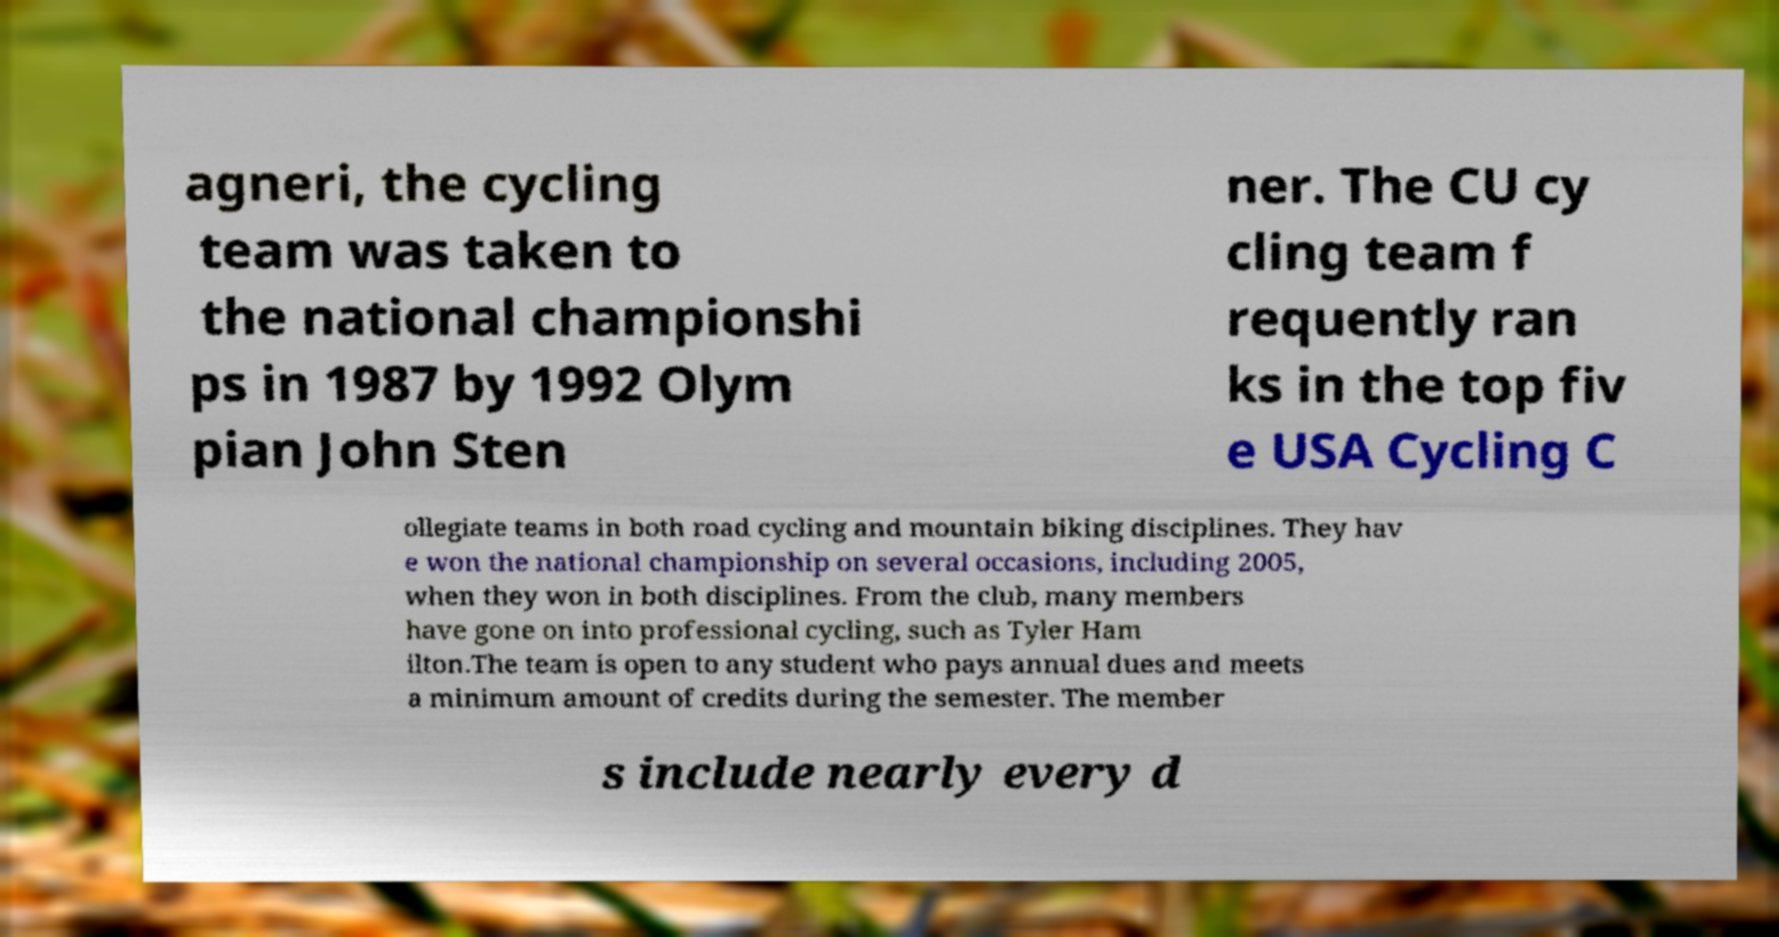Could you extract and type out the text from this image? agneri, the cycling team was taken to the national championshi ps in 1987 by 1992 Olym pian John Sten ner. The CU cy cling team f requently ran ks in the top fiv e USA Cycling C ollegiate teams in both road cycling and mountain biking disciplines. They hav e won the national championship on several occasions, including 2005, when they won in both disciplines. From the club, many members have gone on into professional cycling, such as Tyler Ham ilton.The team is open to any student who pays annual dues and meets a minimum amount of credits during the semester. The member s include nearly every d 